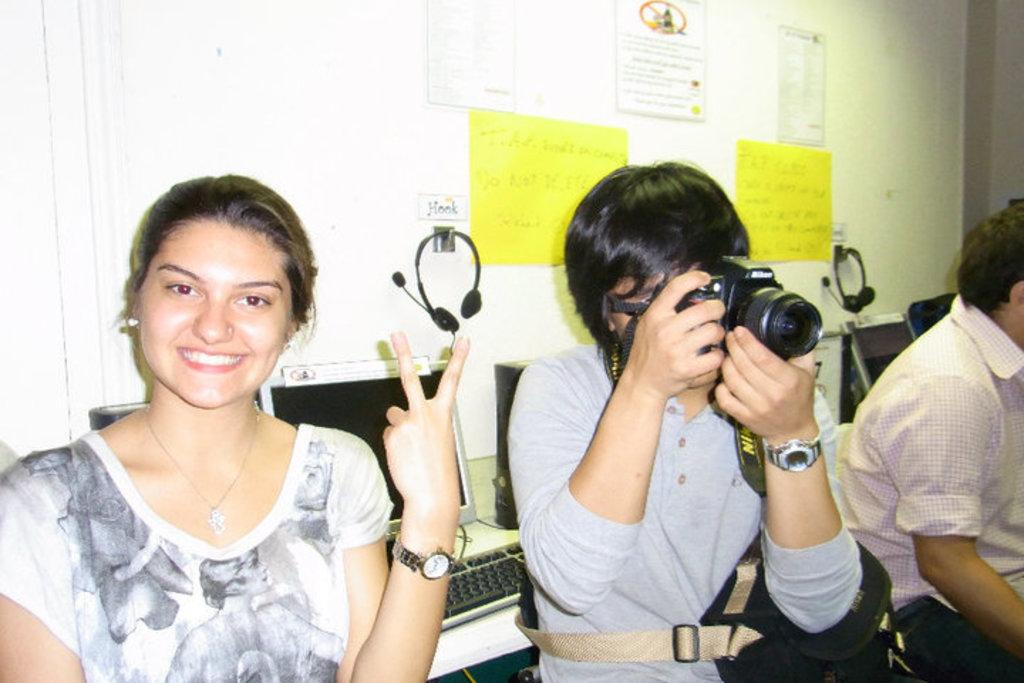What is the person in the image wearing? The person is wearing a grey shirt in the image. What is the person with the grey shirt holding? The person is holding a guitar. How many other people are in the image? There are two other persons in the image, sitting on either side of the person with the guitar. What can be seen in the background of the image? There are computers in the background of the image. What type of string is attached to the guitar in the image? There is no specific type of string mentioned in the image, but the guitar typically has six strings. What is the secretary doing in the image? There is no secretary present in the image. Is there any milk visible in the image? There is no milk present in the image. 